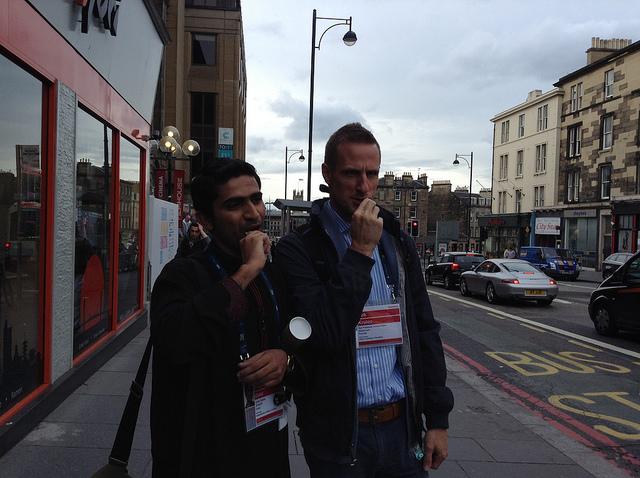Is this a demonstration?
Answer briefly. No. Is this a carnival celebration?
Short answer required. No. Who is walking down the sidewalk?
Concise answer only. 2 men. How many people are talking on the phone?
Be succinct. 0. What color are their badges?
Answer briefly. Red and white. What country was this picture taken in?
Answer briefly. Usa. How many cameras do the men have?
Quick response, please. 0. Are there trees to the right of the people?
Concise answer only. No. Are there over five people visible in this picture?
Write a very short answer. No. What are the two people wearing?
Answer briefly. Jackets. What color is the boy's shirt?
Be succinct. Blue. How many cars are going down the road?
Give a very brief answer. 3. What is sold at the bageri?
Write a very short answer. Food. What is written on the street?
Keep it brief. Bus stop. What kind of structure is the person standing on?
Concise answer only. Sidewalk. What is the red object they are standing around?
Be succinct. Building. What tall object is behind the man on the right?
Be succinct. Lamp post. What are the guys holding?
Give a very brief answer. Toothpicks. Is he wearing a tie?
Quick response, please. No. How many people are shown?
Quick response, please. 2. How many people are holding onto a bike in this image?
Give a very brief answer. 0. What is the man holding under his arm?
Concise answer only. Bag. Do you see a girl with long hair?
Answer briefly. No. Is the man in the picture smiling?
Give a very brief answer. No. How many people in the shot?
Answer briefly. 2. 